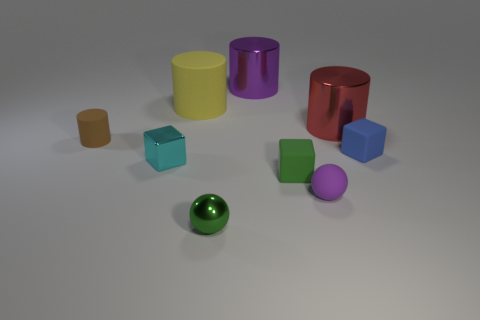Can you tell me which objects in the image have flat surfaces? Certainly! The objects with flat surfaces are the cubes, the cylinders, and the rectangular prism. Each of these shapes exhibit flat, planar surfaces at different angles. 